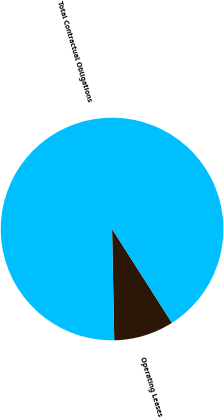<chart> <loc_0><loc_0><loc_500><loc_500><pie_chart><fcel>Operating Leases<fcel>Total Contractual Obligations<nl><fcel>8.73%<fcel>91.27%<nl></chart> 